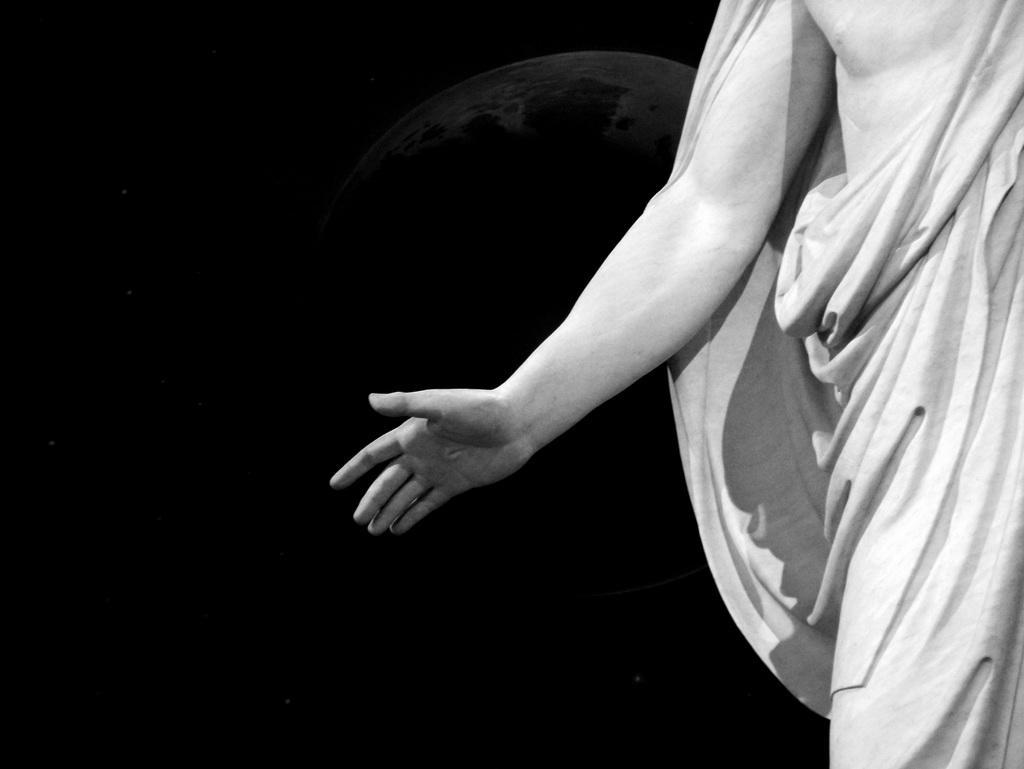Please provide a concise description of this image. This is a black and white picture. On the right side, we see a man is standing and he is trying to do something with his hands. In the background, it is black in color. 